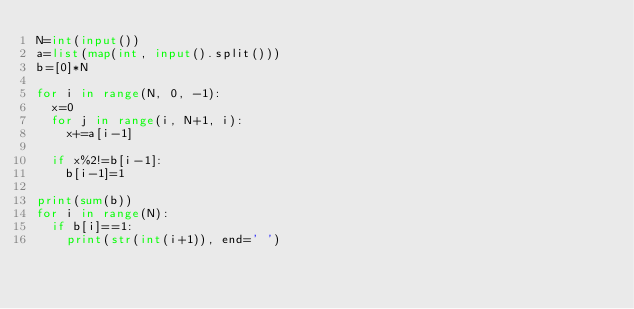<code> <loc_0><loc_0><loc_500><loc_500><_Python_>N=int(input())
a=list(map(int, input().split()))
b=[0]*N

for i in range(N, 0, -1):
  x=0
  for j in range(i, N+1, i):
    x+=a[i-1]
    
  if x%2!=b[i-1]:
    b[i-1]=1
    
print(sum(b))
for i in range(N):
  if b[i]==1:
    print(str(int(i+1)), end=' ')</code> 